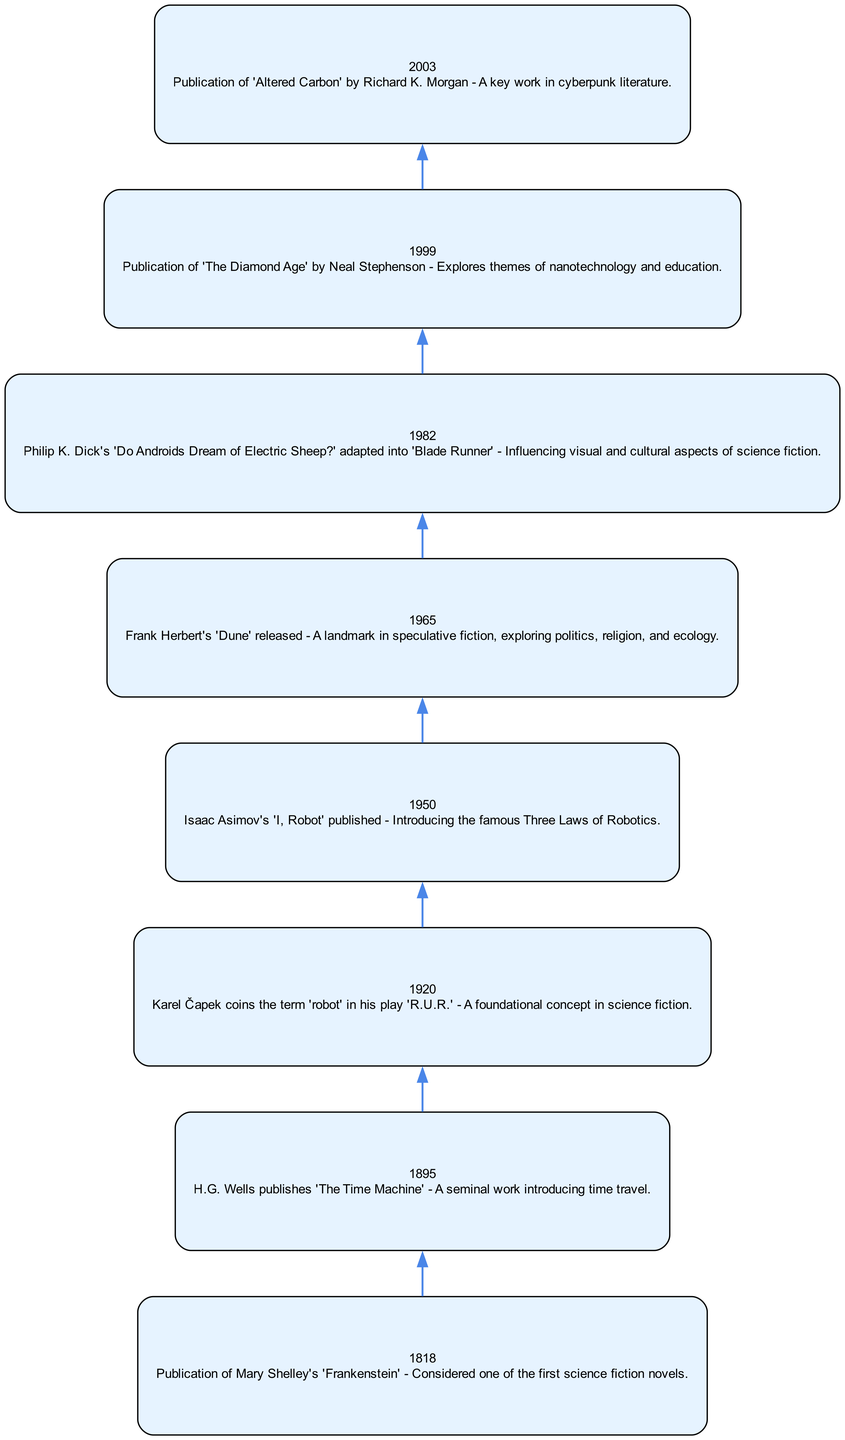What is the year of publication for 'Frankenstein'? The diagram lists the event for the publication of 'Frankenstein' in the year 1818 as one of the major events.
Answer: 1818 Who coined the term 'robot'? According to the diagram, Karel Čapek is noted for coining the term 'robot' in his 1920 play 'R.U.R.'.
Answer: Karel Čapek Which author published 'Dune'? The diagram indicates that Frank Herbert is the author of 'Dune', published in 1965.
Answer: Frank Herbert What event follows the publication of 'I, Robot'? In the flow of events in the diagram, the publication of Frank Herbert's 'Dune' in 1965 follows Isaac Asimov's 'I, Robot', which was published in 1950.
Answer: Publication of 'Dune' How many events are depicted in the timeline? By counting all major events listed in the diagram, there are a total of eight notable events represented.
Answer: 8 Which event explores the theme of nanotechnology? The event pertaining to the publication of 'The Diamond Age' by Neal Stephenson in 1999 in the diagram specifically mentions themes of nanotechnology and education.
Answer: Publication of 'The Diamond Age' What is the connection between 'Do Androids Dream of Electric Sheep?' and 'Blade Runner'? The diagram states that Philip K. Dick's 'Do Androids Dream of Electric Sheep?' was adapted into 'Blade Runner' in 1982, indicating a direct adaptation relationship between the two.
Answer: Adaptation into 'Blade Runner' What was published in 2003? The diagram highlights that 'Altered Carbon' by Richard K. Morgan was published in 2003, marking it as a key work in cyberpunk literature.
Answer: Publication of 'Altered Carbon' 